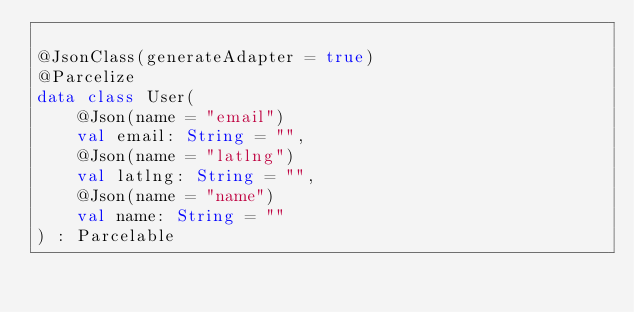<code> <loc_0><loc_0><loc_500><loc_500><_Kotlin_>
@JsonClass(generateAdapter = true)
@Parcelize
data class User(
    @Json(name = "email")
    val email: String = "",
    @Json(name = "latlng")
    val latlng: String = "",
    @Json(name = "name")
    val name: String = ""
) : Parcelable
</code> 